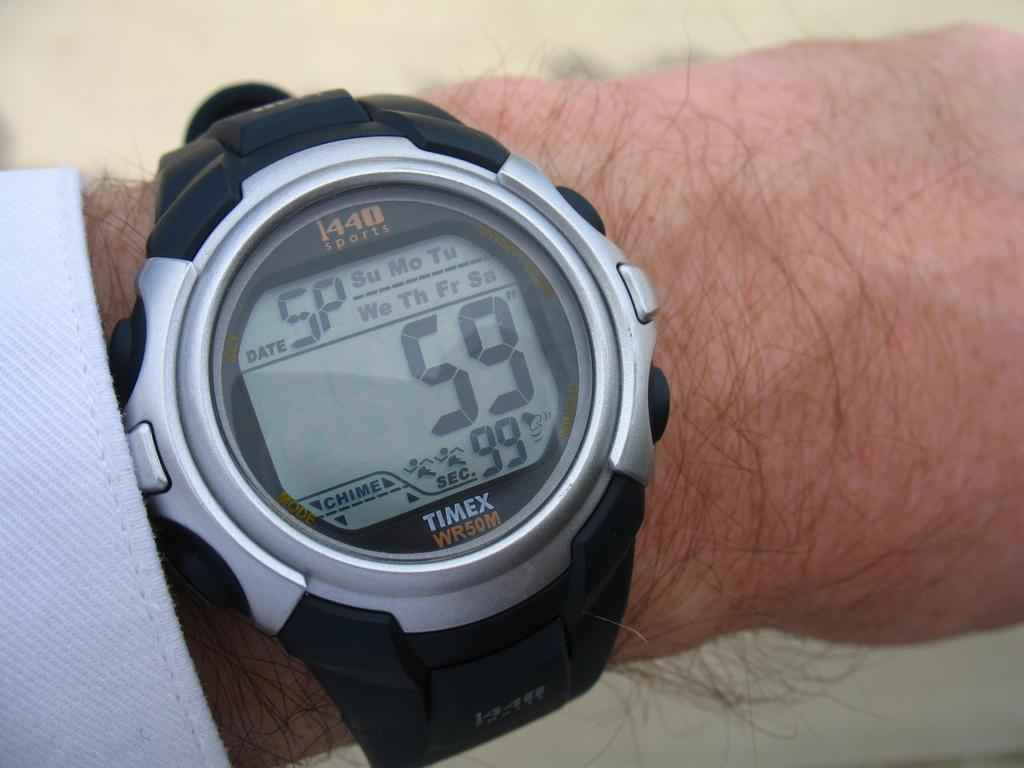<image>
Relay a brief, clear account of the picture shown. A Timex watch has the number 59 on the digital display. 